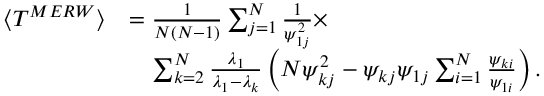Convert formula to latex. <formula><loc_0><loc_0><loc_500><loc_500>\begin{array} { r l } { \langle T ^ { M E R W } \rangle } & { = \frac { 1 } { N ( N - 1 ) } \sum _ { j = 1 } ^ { N } \frac { 1 } { \psi _ { 1 j } ^ { 2 } } \times } \\ & { \quad \sum _ { k = 2 } ^ { N } \frac { \lambda _ { 1 } } { \lambda _ { 1 } - \lambda _ { k } } \left ( N \psi _ { k j } ^ { 2 } - \psi _ { k j } \psi _ { 1 j } \sum _ { i = 1 } ^ { N } \frac { \psi _ { k i } } { \psi _ { 1 i } } \right ) . } \end{array}</formula> 